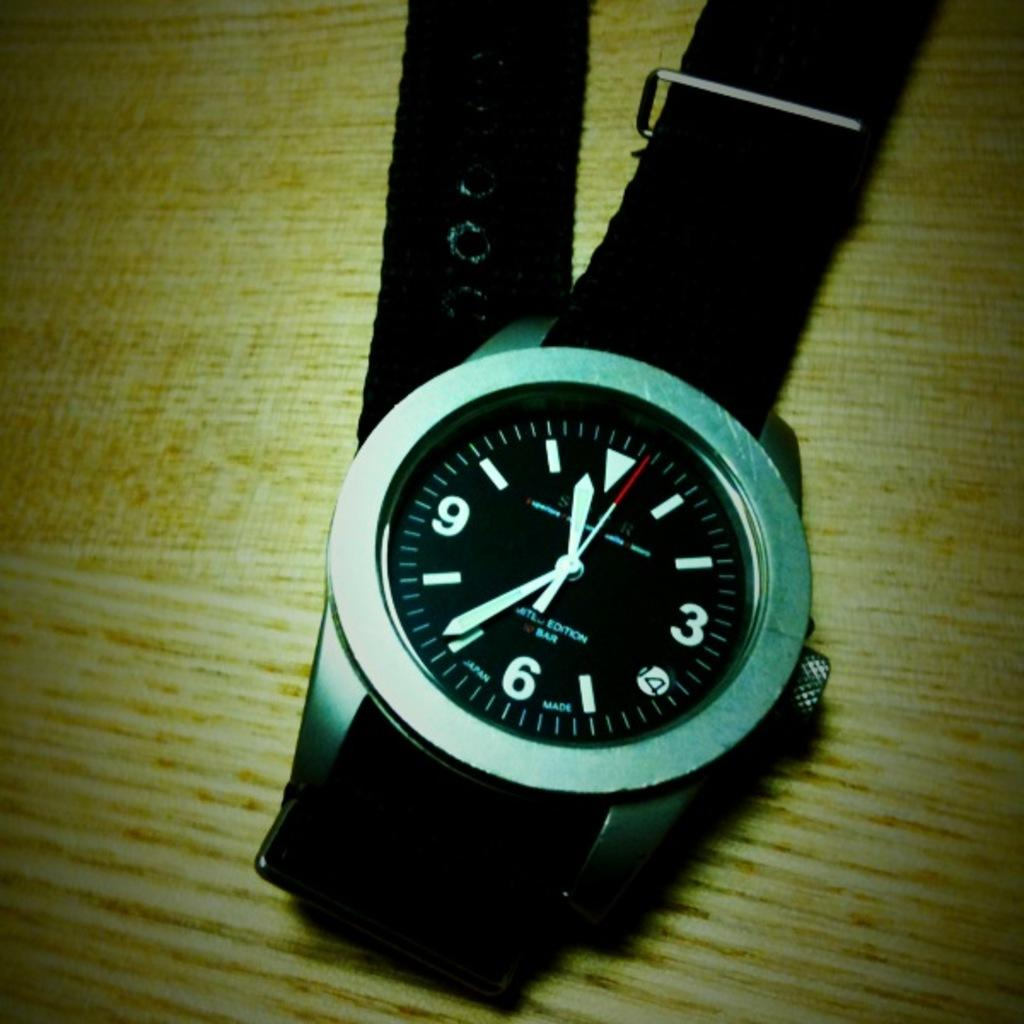<image>
Give a short and clear explanation of the subsequent image. Wristwatch with a black screen and LIMITED EDITION on it as well. 